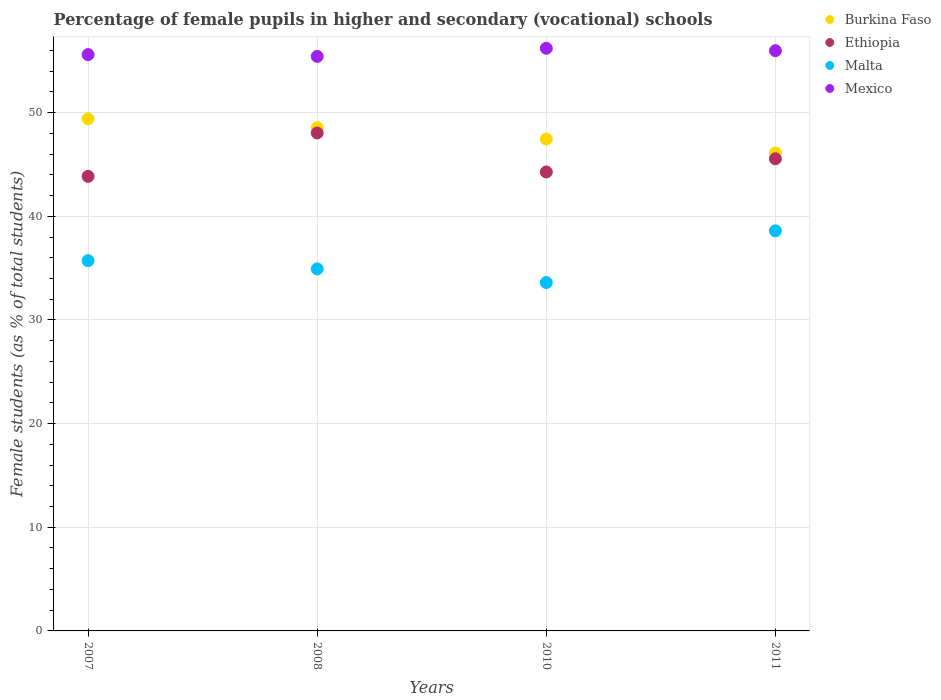How many different coloured dotlines are there?
Offer a terse response. 4. What is the percentage of female pupils in higher and secondary schools in Ethiopia in 2010?
Your answer should be compact. 44.28. Across all years, what is the maximum percentage of female pupils in higher and secondary schools in Mexico?
Your answer should be compact. 56.21. Across all years, what is the minimum percentage of female pupils in higher and secondary schools in Mexico?
Provide a succinct answer. 55.43. What is the total percentage of female pupils in higher and secondary schools in Mexico in the graph?
Your answer should be very brief. 223.22. What is the difference between the percentage of female pupils in higher and secondary schools in Malta in 2007 and that in 2011?
Your answer should be compact. -2.88. What is the difference between the percentage of female pupils in higher and secondary schools in Mexico in 2007 and the percentage of female pupils in higher and secondary schools in Malta in 2008?
Your answer should be compact. 20.67. What is the average percentage of female pupils in higher and secondary schools in Ethiopia per year?
Offer a very short reply. 45.43. In the year 2007, what is the difference between the percentage of female pupils in higher and secondary schools in Malta and percentage of female pupils in higher and secondary schools in Burkina Faso?
Give a very brief answer. -13.69. In how many years, is the percentage of female pupils in higher and secondary schools in Burkina Faso greater than 22 %?
Provide a short and direct response. 4. What is the ratio of the percentage of female pupils in higher and secondary schools in Burkina Faso in 2007 to that in 2008?
Ensure brevity in your answer.  1.02. What is the difference between the highest and the second highest percentage of female pupils in higher and secondary schools in Malta?
Give a very brief answer. 2.88. What is the difference between the highest and the lowest percentage of female pupils in higher and secondary schools in Mexico?
Make the answer very short. 0.78. Is the sum of the percentage of female pupils in higher and secondary schools in Mexico in 2007 and 2010 greater than the maximum percentage of female pupils in higher and secondary schools in Malta across all years?
Provide a succinct answer. Yes. Is it the case that in every year, the sum of the percentage of female pupils in higher and secondary schools in Burkina Faso and percentage of female pupils in higher and secondary schools in Malta  is greater than the sum of percentage of female pupils in higher and secondary schools in Mexico and percentage of female pupils in higher and secondary schools in Ethiopia?
Your answer should be very brief. No. Is it the case that in every year, the sum of the percentage of female pupils in higher and secondary schools in Mexico and percentage of female pupils in higher and secondary schools in Malta  is greater than the percentage of female pupils in higher and secondary schools in Burkina Faso?
Your answer should be very brief. Yes. Is the percentage of female pupils in higher and secondary schools in Malta strictly greater than the percentage of female pupils in higher and secondary schools in Mexico over the years?
Offer a very short reply. No. How many dotlines are there?
Make the answer very short. 4. Does the graph contain grids?
Offer a very short reply. Yes. Where does the legend appear in the graph?
Provide a succinct answer. Top right. How many legend labels are there?
Offer a very short reply. 4. What is the title of the graph?
Offer a very short reply. Percentage of female pupils in higher and secondary (vocational) schools. Does "Malaysia" appear as one of the legend labels in the graph?
Your response must be concise. No. What is the label or title of the X-axis?
Make the answer very short. Years. What is the label or title of the Y-axis?
Ensure brevity in your answer.  Female students (as % of total students). What is the Female students (as % of total students) in Burkina Faso in 2007?
Make the answer very short. 49.41. What is the Female students (as % of total students) in Ethiopia in 2007?
Give a very brief answer. 43.85. What is the Female students (as % of total students) of Malta in 2007?
Give a very brief answer. 35.72. What is the Female students (as % of total students) in Mexico in 2007?
Your answer should be very brief. 55.6. What is the Female students (as % of total students) in Burkina Faso in 2008?
Give a very brief answer. 48.56. What is the Female students (as % of total students) of Ethiopia in 2008?
Give a very brief answer. 48.04. What is the Female students (as % of total students) in Malta in 2008?
Your answer should be very brief. 34.93. What is the Female students (as % of total students) of Mexico in 2008?
Offer a very short reply. 55.43. What is the Female students (as % of total students) of Burkina Faso in 2010?
Ensure brevity in your answer.  47.45. What is the Female students (as % of total students) in Ethiopia in 2010?
Provide a succinct answer. 44.28. What is the Female students (as % of total students) of Malta in 2010?
Keep it short and to the point. 33.61. What is the Female students (as % of total students) in Mexico in 2010?
Your answer should be compact. 56.21. What is the Female students (as % of total students) of Burkina Faso in 2011?
Make the answer very short. 46.11. What is the Female students (as % of total students) in Ethiopia in 2011?
Make the answer very short. 45.55. What is the Female students (as % of total students) of Malta in 2011?
Offer a very short reply. 38.6. What is the Female students (as % of total students) of Mexico in 2011?
Provide a short and direct response. 55.98. Across all years, what is the maximum Female students (as % of total students) of Burkina Faso?
Provide a short and direct response. 49.41. Across all years, what is the maximum Female students (as % of total students) in Ethiopia?
Give a very brief answer. 48.04. Across all years, what is the maximum Female students (as % of total students) of Malta?
Provide a succinct answer. 38.6. Across all years, what is the maximum Female students (as % of total students) in Mexico?
Your answer should be very brief. 56.21. Across all years, what is the minimum Female students (as % of total students) of Burkina Faso?
Provide a succinct answer. 46.11. Across all years, what is the minimum Female students (as % of total students) of Ethiopia?
Offer a very short reply. 43.85. Across all years, what is the minimum Female students (as % of total students) in Malta?
Provide a short and direct response. 33.61. Across all years, what is the minimum Female students (as % of total students) of Mexico?
Make the answer very short. 55.43. What is the total Female students (as % of total students) of Burkina Faso in the graph?
Give a very brief answer. 191.53. What is the total Female students (as % of total students) in Ethiopia in the graph?
Your answer should be very brief. 181.72. What is the total Female students (as % of total students) of Malta in the graph?
Give a very brief answer. 142.85. What is the total Female students (as % of total students) in Mexico in the graph?
Keep it short and to the point. 223.22. What is the difference between the Female students (as % of total students) of Burkina Faso in 2007 and that in 2008?
Provide a short and direct response. 0.85. What is the difference between the Female students (as % of total students) in Ethiopia in 2007 and that in 2008?
Provide a short and direct response. -4.19. What is the difference between the Female students (as % of total students) in Malta in 2007 and that in 2008?
Your answer should be compact. 0.8. What is the difference between the Female students (as % of total students) of Mexico in 2007 and that in 2008?
Offer a very short reply. 0.17. What is the difference between the Female students (as % of total students) in Burkina Faso in 2007 and that in 2010?
Keep it short and to the point. 1.96. What is the difference between the Female students (as % of total students) of Ethiopia in 2007 and that in 2010?
Make the answer very short. -0.42. What is the difference between the Female students (as % of total students) in Malta in 2007 and that in 2010?
Your response must be concise. 2.11. What is the difference between the Female students (as % of total students) of Mexico in 2007 and that in 2010?
Provide a succinct answer. -0.61. What is the difference between the Female students (as % of total students) in Burkina Faso in 2007 and that in 2011?
Your response must be concise. 3.3. What is the difference between the Female students (as % of total students) in Ethiopia in 2007 and that in 2011?
Your response must be concise. -1.7. What is the difference between the Female students (as % of total students) in Malta in 2007 and that in 2011?
Keep it short and to the point. -2.88. What is the difference between the Female students (as % of total students) of Mexico in 2007 and that in 2011?
Make the answer very short. -0.38. What is the difference between the Female students (as % of total students) in Burkina Faso in 2008 and that in 2010?
Provide a succinct answer. 1.11. What is the difference between the Female students (as % of total students) in Ethiopia in 2008 and that in 2010?
Give a very brief answer. 3.76. What is the difference between the Female students (as % of total students) of Malta in 2008 and that in 2010?
Offer a very short reply. 1.32. What is the difference between the Female students (as % of total students) in Mexico in 2008 and that in 2010?
Your answer should be very brief. -0.78. What is the difference between the Female students (as % of total students) in Burkina Faso in 2008 and that in 2011?
Give a very brief answer. 2.45. What is the difference between the Female students (as % of total students) in Ethiopia in 2008 and that in 2011?
Give a very brief answer. 2.49. What is the difference between the Female students (as % of total students) of Malta in 2008 and that in 2011?
Give a very brief answer. -3.67. What is the difference between the Female students (as % of total students) in Mexico in 2008 and that in 2011?
Keep it short and to the point. -0.55. What is the difference between the Female students (as % of total students) of Burkina Faso in 2010 and that in 2011?
Provide a short and direct response. 1.35. What is the difference between the Female students (as % of total students) in Ethiopia in 2010 and that in 2011?
Your response must be concise. -1.27. What is the difference between the Female students (as % of total students) of Malta in 2010 and that in 2011?
Provide a short and direct response. -4.99. What is the difference between the Female students (as % of total students) in Mexico in 2010 and that in 2011?
Your answer should be very brief. 0.23. What is the difference between the Female students (as % of total students) of Burkina Faso in 2007 and the Female students (as % of total students) of Ethiopia in 2008?
Offer a very short reply. 1.37. What is the difference between the Female students (as % of total students) of Burkina Faso in 2007 and the Female students (as % of total students) of Malta in 2008?
Keep it short and to the point. 14.48. What is the difference between the Female students (as % of total students) in Burkina Faso in 2007 and the Female students (as % of total students) in Mexico in 2008?
Keep it short and to the point. -6.02. What is the difference between the Female students (as % of total students) in Ethiopia in 2007 and the Female students (as % of total students) in Malta in 2008?
Provide a succinct answer. 8.93. What is the difference between the Female students (as % of total students) in Ethiopia in 2007 and the Female students (as % of total students) in Mexico in 2008?
Offer a terse response. -11.57. What is the difference between the Female students (as % of total students) in Malta in 2007 and the Female students (as % of total students) in Mexico in 2008?
Provide a succinct answer. -19.7. What is the difference between the Female students (as % of total students) of Burkina Faso in 2007 and the Female students (as % of total students) of Ethiopia in 2010?
Your answer should be very brief. 5.13. What is the difference between the Female students (as % of total students) of Burkina Faso in 2007 and the Female students (as % of total students) of Malta in 2010?
Keep it short and to the point. 15.8. What is the difference between the Female students (as % of total students) of Burkina Faso in 2007 and the Female students (as % of total students) of Mexico in 2010?
Provide a succinct answer. -6.8. What is the difference between the Female students (as % of total students) of Ethiopia in 2007 and the Female students (as % of total students) of Malta in 2010?
Your answer should be compact. 10.24. What is the difference between the Female students (as % of total students) in Ethiopia in 2007 and the Female students (as % of total students) in Mexico in 2010?
Give a very brief answer. -12.36. What is the difference between the Female students (as % of total students) of Malta in 2007 and the Female students (as % of total students) of Mexico in 2010?
Your answer should be compact. -20.49. What is the difference between the Female students (as % of total students) in Burkina Faso in 2007 and the Female students (as % of total students) in Ethiopia in 2011?
Offer a terse response. 3.86. What is the difference between the Female students (as % of total students) in Burkina Faso in 2007 and the Female students (as % of total students) in Malta in 2011?
Keep it short and to the point. 10.81. What is the difference between the Female students (as % of total students) of Burkina Faso in 2007 and the Female students (as % of total students) of Mexico in 2011?
Make the answer very short. -6.57. What is the difference between the Female students (as % of total students) of Ethiopia in 2007 and the Female students (as % of total students) of Malta in 2011?
Give a very brief answer. 5.25. What is the difference between the Female students (as % of total students) in Ethiopia in 2007 and the Female students (as % of total students) in Mexico in 2011?
Provide a succinct answer. -12.13. What is the difference between the Female students (as % of total students) in Malta in 2007 and the Female students (as % of total students) in Mexico in 2011?
Give a very brief answer. -20.26. What is the difference between the Female students (as % of total students) of Burkina Faso in 2008 and the Female students (as % of total students) of Ethiopia in 2010?
Your answer should be very brief. 4.28. What is the difference between the Female students (as % of total students) in Burkina Faso in 2008 and the Female students (as % of total students) in Malta in 2010?
Your answer should be very brief. 14.95. What is the difference between the Female students (as % of total students) of Burkina Faso in 2008 and the Female students (as % of total students) of Mexico in 2010?
Offer a terse response. -7.65. What is the difference between the Female students (as % of total students) in Ethiopia in 2008 and the Female students (as % of total students) in Malta in 2010?
Offer a terse response. 14.43. What is the difference between the Female students (as % of total students) in Ethiopia in 2008 and the Female students (as % of total students) in Mexico in 2010?
Ensure brevity in your answer.  -8.17. What is the difference between the Female students (as % of total students) in Malta in 2008 and the Female students (as % of total students) in Mexico in 2010?
Your answer should be compact. -21.28. What is the difference between the Female students (as % of total students) in Burkina Faso in 2008 and the Female students (as % of total students) in Ethiopia in 2011?
Give a very brief answer. 3.01. What is the difference between the Female students (as % of total students) of Burkina Faso in 2008 and the Female students (as % of total students) of Malta in 2011?
Provide a succinct answer. 9.96. What is the difference between the Female students (as % of total students) in Burkina Faso in 2008 and the Female students (as % of total students) in Mexico in 2011?
Ensure brevity in your answer.  -7.42. What is the difference between the Female students (as % of total students) in Ethiopia in 2008 and the Female students (as % of total students) in Malta in 2011?
Offer a terse response. 9.44. What is the difference between the Female students (as % of total students) of Ethiopia in 2008 and the Female students (as % of total students) of Mexico in 2011?
Provide a short and direct response. -7.94. What is the difference between the Female students (as % of total students) of Malta in 2008 and the Female students (as % of total students) of Mexico in 2011?
Ensure brevity in your answer.  -21.05. What is the difference between the Female students (as % of total students) in Burkina Faso in 2010 and the Female students (as % of total students) in Ethiopia in 2011?
Make the answer very short. 1.9. What is the difference between the Female students (as % of total students) of Burkina Faso in 2010 and the Female students (as % of total students) of Malta in 2011?
Provide a succinct answer. 8.86. What is the difference between the Female students (as % of total students) in Burkina Faso in 2010 and the Female students (as % of total students) in Mexico in 2011?
Your answer should be compact. -8.53. What is the difference between the Female students (as % of total students) in Ethiopia in 2010 and the Female students (as % of total students) in Malta in 2011?
Your answer should be very brief. 5.68. What is the difference between the Female students (as % of total students) of Ethiopia in 2010 and the Female students (as % of total students) of Mexico in 2011?
Offer a terse response. -11.7. What is the difference between the Female students (as % of total students) of Malta in 2010 and the Female students (as % of total students) of Mexico in 2011?
Offer a terse response. -22.37. What is the average Female students (as % of total students) of Burkina Faso per year?
Provide a succinct answer. 47.88. What is the average Female students (as % of total students) of Ethiopia per year?
Offer a very short reply. 45.43. What is the average Female students (as % of total students) of Malta per year?
Make the answer very short. 35.71. What is the average Female students (as % of total students) in Mexico per year?
Make the answer very short. 55.8. In the year 2007, what is the difference between the Female students (as % of total students) in Burkina Faso and Female students (as % of total students) in Ethiopia?
Offer a very short reply. 5.56. In the year 2007, what is the difference between the Female students (as % of total students) of Burkina Faso and Female students (as % of total students) of Malta?
Your answer should be compact. 13.69. In the year 2007, what is the difference between the Female students (as % of total students) of Burkina Faso and Female students (as % of total students) of Mexico?
Your answer should be very brief. -6.19. In the year 2007, what is the difference between the Female students (as % of total students) in Ethiopia and Female students (as % of total students) in Malta?
Ensure brevity in your answer.  8.13. In the year 2007, what is the difference between the Female students (as % of total students) of Ethiopia and Female students (as % of total students) of Mexico?
Provide a succinct answer. -11.75. In the year 2007, what is the difference between the Female students (as % of total students) of Malta and Female students (as % of total students) of Mexico?
Ensure brevity in your answer.  -19.88. In the year 2008, what is the difference between the Female students (as % of total students) of Burkina Faso and Female students (as % of total students) of Ethiopia?
Give a very brief answer. 0.52. In the year 2008, what is the difference between the Female students (as % of total students) of Burkina Faso and Female students (as % of total students) of Malta?
Keep it short and to the point. 13.63. In the year 2008, what is the difference between the Female students (as % of total students) in Burkina Faso and Female students (as % of total students) in Mexico?
Your answer should be very brief. -6.87. In the year 2008, what is the difference between the Female students (as % of total students) of Ethiopia and Female students (as % of total students) of Malta?
Your answer should be very brief. 13.11. In the year 2008, what is the difference between the Female students (as % of total students) in Ethiopia and Female students (as % of total students) in Mexico?
Your answer should be very brief. -7.39. In the year 2008, what is the difference between the Female students (as % of total students) of Malta and Female students (as % of total students) of Mexico?
Your response must be concise. -20.5. In the year 2010, what is the difference between the Female students (as % of total students) in Burkina Faso and Female students (as % of total students) in Ethiopia?
Ensure brevity in your answer.  3.18. In the year 2010, what is the difference between the Female students (as % of total students) of Burkina Faso and Female students (as % of total students) of Malta?
Provide a short and direct response. 13.85. In the year 2010, what is the difference between the Female students (as % of total students) in Burkina Faso and Female students (as % of total students) in Mexico?
Your response must be concise. -8.76. In the year 2010, what is the difference between the Female students (as % of total students) of Ethiopia and Female students (as % of total students) of Malta?
Your response must be concise. 10.67. In the year 2010, what is the difference between the Female students (as % of total students) in Ethiopia and Female students (as % of total students) in Mexico?
Make the answer very short. -11.93. In the year 2010, what is the difference between the Female students (as % of total students) of Malta and Female students (as % of total students) of Mexico?
Keep it short and to the point. -22.6. In the year 2011, what is the difference between the Female students (as % of total students) in Burkina Faso and Female students (as % of total students) in Ethiopia?
Make the answer very short. 0.56. In the year 2011, what is the difference between the Female students (as % of total students) of Burkina Faso and Female students (as % of total students) of Malta?
Make the answer very short. 7.51. In the year 2011, what is the difference between the Female students (as % of total students) of Burkina Faso and Female students (as % of total students) of Mexico?
Your answer should be compact. -9.87. In the year 2011, what is the difference between the Female students (as % of total students) in Ethiopia and Female students (as % of total students) in Malta?
Keep it short and to the point. 6.95. In the year 2011, what is the difference between the Female students (as % of total students) of Ethiopia and Female students (as % of total students) of Mexico?
Make the answer very short. -10.43. In the year 2011, what is the difference between the Female students (as % of total students) of Malta and Female students (as % of total students) of Mexico?
Your answer should be compact. -17.38. What is the ratio of the Female students (as % of total students) of Burkina Faso in 2007 to that in 2008?
Offer a very short reply. 1.02. What is the ratio of the Female students (as % of total students) of Ethiopia in 2007 to that in 2008?
Make the answer very short. 0.91. What is the ratio of the Female students (as % of total students) in Malta in 2007 to that in 2008?
Keep it short and to the point. 1.02. What is the ratio of the Female students (as % of total students) of Burkina Faso in 2007 to that in 2010?
Give a very brief answer. 1.04. What is the ratio of the Female students (as % of total students) in Malta in 2007 to that in 2010?
Offer a terse response. 1.06. What is the ratio of the Female students (as % of total students) in Burkina Faso in 2007 to that in 2011?
Your response must be concise. 1.07. What is the ratio of the Female students (as % of total students) of Ethiopia in 2007 to that in 2011?
Provide a succinct answer. 0.96. What is the ratio of the Female students (as % of total students) in Malta in 2007 to that in 2011?
Offer a terse response. 0.93. What is the ratio of the Female students (as % of total students) in Mexico in 2007 to that in 2011?
Your answer should be very brief. 0.99. What is the ratio of the Female students (as % of total students) of Burkina Faso in 2008 to that in 2010?
Keep it short and to the point. 1.02. What is the ratio of the Female students (as % of total students) of Ethiopia in 2008 to that in 2010?
Offer a very short reply. 1.08. What is the ratio of the Female students (as % of total students) of Malta in 2008 to that in 2010?
Offer a terse response. 1.04. What is the ratio of the Female students (as % of total students) in Mexico in 2008 to that in 2010?
Give a very brief answer. 0.99. What is the ratio of the Female students (as % of total students) in Burkina Faso in 2008 to that in 2011?
Give a very brief answer. 1.05. What is the ratio of the Female students (as % of total students) in Ethiopia in 2008 to that in 2011?
Offer a very short reply. 1.05. What is the ratio of the Female students (as % of total students) in Malta in 2008 to that in 2011?
Offer a terse response. 0.9. What is the ratio of the Female students (as % of total students) of Mexico in 2008 to that in 2011?
Offer a very short reply. 0.99. What is the ratio of the Female students (as % of total students) of Burkina Faso in 2010 to that in 2011?
Your response must be concise. 1.03. What is the ratio of the Female students (as % of total students) in Ethiopia in 2010 to that in 2011?
Provide a succinct answer. 0.97. What is the ratio of the Female students (as % of total students) of Malta in 2010 to that in 2011?
Give a very brief answer. 0.87. What is the difference between the highest and the second highest Female students (as % of total students) in Burkina Faso?
Your response must be concise. 0.85. What is the difference between the highest and the second highest Female students (as % of total students) in Ethiopia?
Offer a very short reply. 2.49. What is the difference between the highest and the second highest Female students (as % of total students) in Malta?
Offer a terse response. 2.88. What is the difference between the highest and the second highest Female students (as % of total students) in Mexico?
Keep it short and to the point. 0.23. What is the difference between the highest and the lowest Female students (as % of total students) in Burkina Faso?
Offer a terse response. 3.3. What is the difference between the highest and the lowest Female students (as % of total students) in Ethiopia?
Offer a very short reply. 4.19. What is the difference between the highest and the lowest Female students (as % of total students) in Malta?
Make the answer very short. 4.99. What is the difference between the highest and the lowest Female students (as % of total students) in Mexico?
Ensure brevity in your answer.  0.78. 